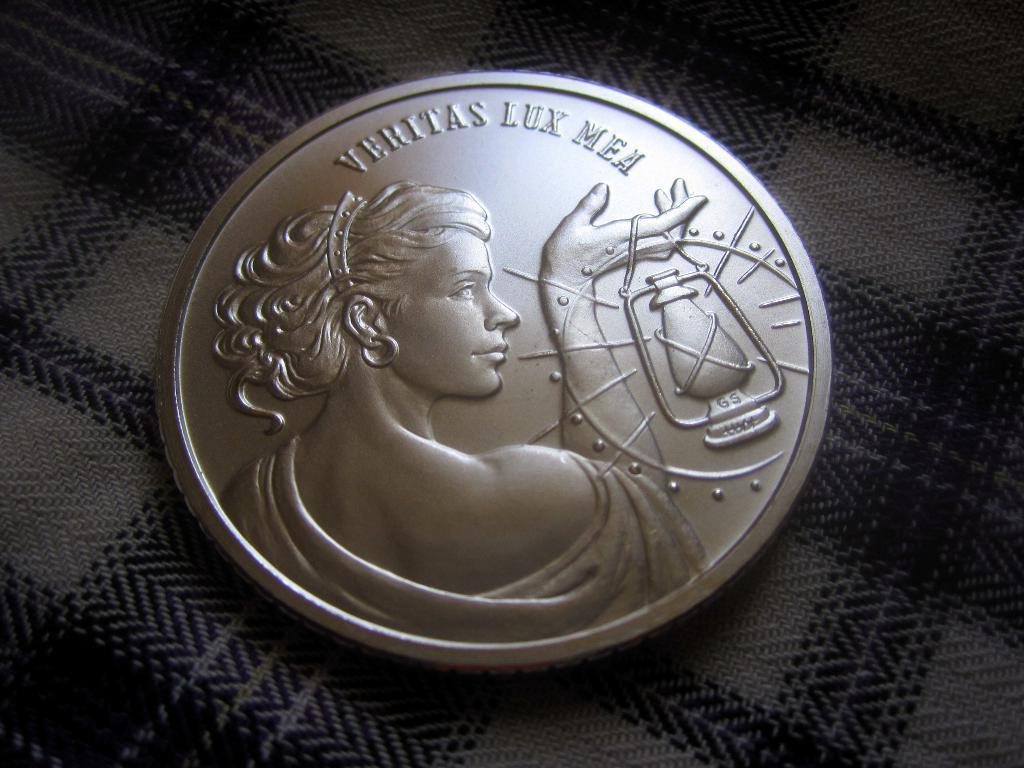What text is on the top of this coin?
Provide a succinct answer. Veritas lux mea. 